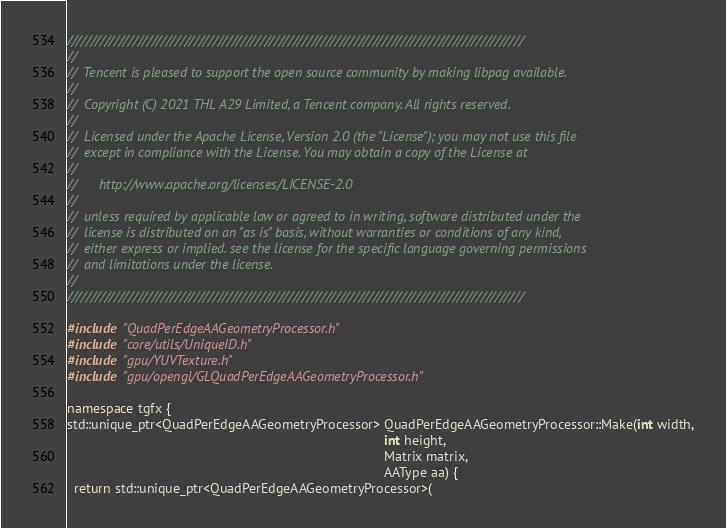<code> <loc_0><loc_0><loc_500><loc_500><_C++_>/////////////////////////////////////////////////////////////////////////////////////////////////
//
//  Tencent is pleased to support the open source community by making libpag available.
//
//  Copyright (C) 2021 THL A29 Limited, a Tencent company. All rights reserved.
//
//  Licensed under the Apache License, Version 2.0 (the "License"); you may not use this file
//  except in compliance with the License. You may obtain a copy of the License at
//
//      http://www.apache.org/licenses/LICENSE-2.0
//
//  unless required by applicable law or agreed to in writing, software distributed under the
//  license is distributed on an "as is" basis, without warranties or conditions of any kind,
//  either express or implied. see the license for the specific language governing permissions
//  and limitations under the license.
//
/////////////////////////////////////////////////////////////////////////////////////////////////

#include "QuadPerEdgeAAGeometryProcessor.h"
#include "core/utils/UniqueID.h"
#include "gpu/YUVTexture.h"
#include "gpu/opengl/GLQuadPerEdgeAAGeometryProcessor.h"

namespace tgfx {
std::unique_ptr<QuadPerEdgeAAGeometryProcessor> QuadPerEdgeAAGeometryProcessor::Make(int width,
                                                                                     int height,
                                                                                     Matrix matrix,
                                                                                     AAType aa) {
  return std::unique_ptr<QuadPerEdgeAAGeometryProcessor>(</code> 